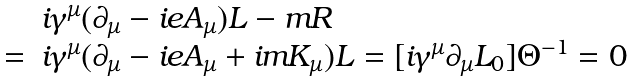Convert formula to latex. <formula><loc_0><loc_0><loc_500><loc_500>\begin{array} { l l } & i \gamma ^ { \mu } ( \partial _ { \mu } - i e A _ { \mu } ) L - m R \\ = & i \gamma ^ { \mu } ( \partial _ { \mu } - i e A _ { \mu } + i m K _ { \mu } ) L = [ i \gamma ^ { \mu } \partial _ { \mu } L _ { 0 } ] \Theta ^ { - 1 } = 0 \end{array}</formula> 